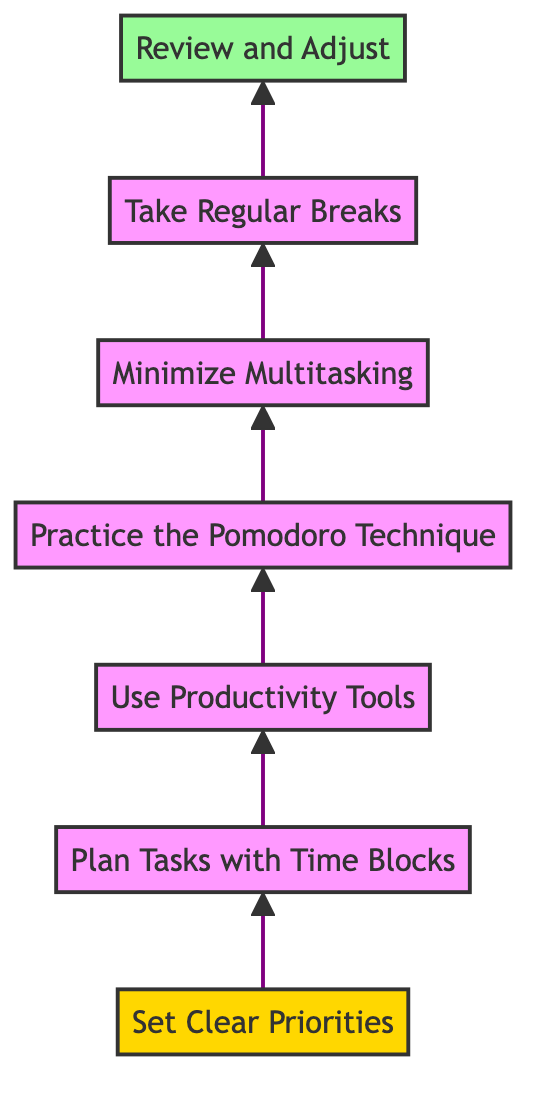What is the title of the first step in improving daily productivity? The first step listed in the diagram is "Set Clear Priorities." This is identified as the starting point of the flow chart, which is at the bottom of the diagram.
Answer: Set Clear Priorities How many total steps are there in the diagram? The diagram presents a total of seven steps, starting from "Set Clear Priorities" at the bottom to "Review and Adjust" at the top.
Answer: Seven Which step comes immediately before "Take Regular Breaks"? The step that comes directly before "Take Regular Breaks" is "Minimize Multitasking." This can be observed by following the arrow flow from the lower node to the upper node.
Answer: Minimize Multitasking What is the focus of step four in the productivity improvement process? Step four is focused on "Practice the Pomodoro Technique," which is indicated clearly in the flow of the diagram as the fourth item from the bottom.
Answer: Practice the Pomodoro Technique Which step has a distinct background color in the diagram? The step that has a distinct background color is "Review and Adjust," which is shaded in light green, indicating it has a specific significance as the final step in the process.
Answer: Review and Adjust What productivity tool-related step is placed third in the diagram? The third step specified in the flow chart is "Use Productivity Tools," demonstrating its position and importance in the overall productivity improvement strategy.
Answer: Use Productivity Tools What action is advised at the end of the day according to the diagram? The diagram advises to "Review and Adjust" at the end of the day, making it clear that this is an essential conclusion to the day's productivity activities.
Answer: Review and Adjust 